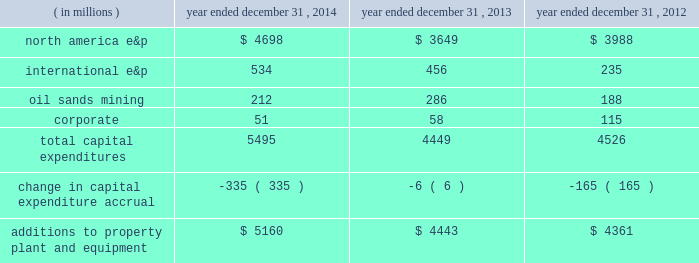Additions to property , plant and equipment are our most significant use of cash and cash equivalents .
The table shows capital expenditures related to continuing operations by segment and reconciles to additions to property , plant and equipment as presented in the consolidated statements of cash flows for 2014 , 2013 and 2012: .
As of december 31 , 2014 , we had repurchased a total of 121 million common shares at a cost of $ 4.7 billion , including 29 million shares at a cost of $ 1 billion in the first six months of 2014 and 14 million shares at a cost of $ 500 million in the third quarter of 2013 .
See item 8 .
Financial statements and supplementary data 2013 note 22 to the consolidated financial statements for discussion of purchases of common stock .
Liquidity and capital resources our main sources of liquidity are cash and cash equivalents , internally generated cash flow from operations , continued access to capital markets , our committed revolving credit facility and sales of non-strategic assets .
Our working capital requirements are supported by these sources and we may issue commercial paper backed by our $ 2.5 billion revolving credit facility to meet short-term cash requirements .
Because of the alternatives available to us as discussed above and access to capital markets through the shelf registration discussed below , we believe that our short-term and long-term liquidity is adequate to fund not only our current operations , but also our near-term and long-term funding requirements including our capital spending programs , dividend payments , defined benefit plan contributions , repayment of debt maturities and other amounts that may ultimately be paid in connection with contingencies .
At december 31 , 2014 , we had approximately $ 4.9 billion of liquidity consisting of $ 2.4 billion in cash and cash equivalents and $ 2.5 billion availability under our revolving credit facility .
As discussed in more detail below in 201coutlook 201d , we are targeting a $ 3.5 billion budget for 2015 .
Based on our projected 2015 cash outlays for our capital program and dividends , we expect to outspend our cash flows from operations for the year .
We will be constantly monitoring our available liquidity during 2015 and we have the flexibility to adjust our budget throughout the year in response to the commodity price environment .
We will also continue to drive the fundamentals of expense management , including organizational capacity and operational reliability .
Capital resources credit arrangements and borrowings in may 2014 , we amended our $ 2.5 billion unsecured revolving credit facility and extended the maturity to may 2019 .
See note 16 to the consolidated financial statements for additional terms and rates .
At december 31 , 2014 , we had no borrowings against our revolving credit facility and no amounts outstanding under our u.s .
Commercial paper program that is backed by the revolving credit facility .
At december 31 , 2014 , we had $ 6391 million in long-term debt outstanding , and $ 1068 million is due within one year , of which the majority is due in the fourth quarter of 2015 .
We do not have any triggers on any of our corporate debt that would cause an event of default in the case of a downgrade of our credit ratings .
Shelf registration we have a universal shelf registration statement filed with the sec , under which we , as "well-known seasoned issuer" for purposes of sec rules , have the ability to issue and sell an indeterminate amount of various types of debt and equity securities from time to time. .
By how much did total capital expenditures increase from 2013 to 2014? 
Computations: ((5495 - 4449) / 4449)
Answer: 0.23511. 